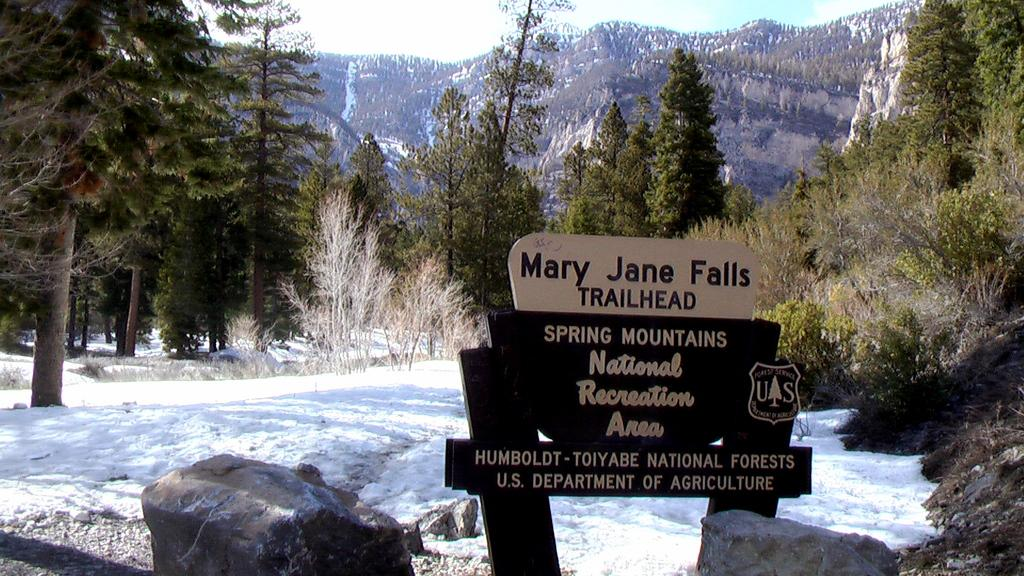What is constructed using wooden poles in the image? There are boards on wooden poles in the image. What type of vegetation can be seen in the image? There are plants and trees in the image. What is the weather like in the image? There is snow visible in the image, indicating a cold climate. What can be seen in the distance in the image? There is a mountain in the background of the image. What is visible above the mountain in the image? The sky is visible in the background of the image. What type of club is being used to hit the ball in the image? There is no ball or club present in the image; it features boards on wooden poles, plants, trees, snow, a mountain, and the sky. What kind of test is being conducted on the plants in the image? There is no test being conducted on the plants in the image; they are simply part of the natural landscape. 